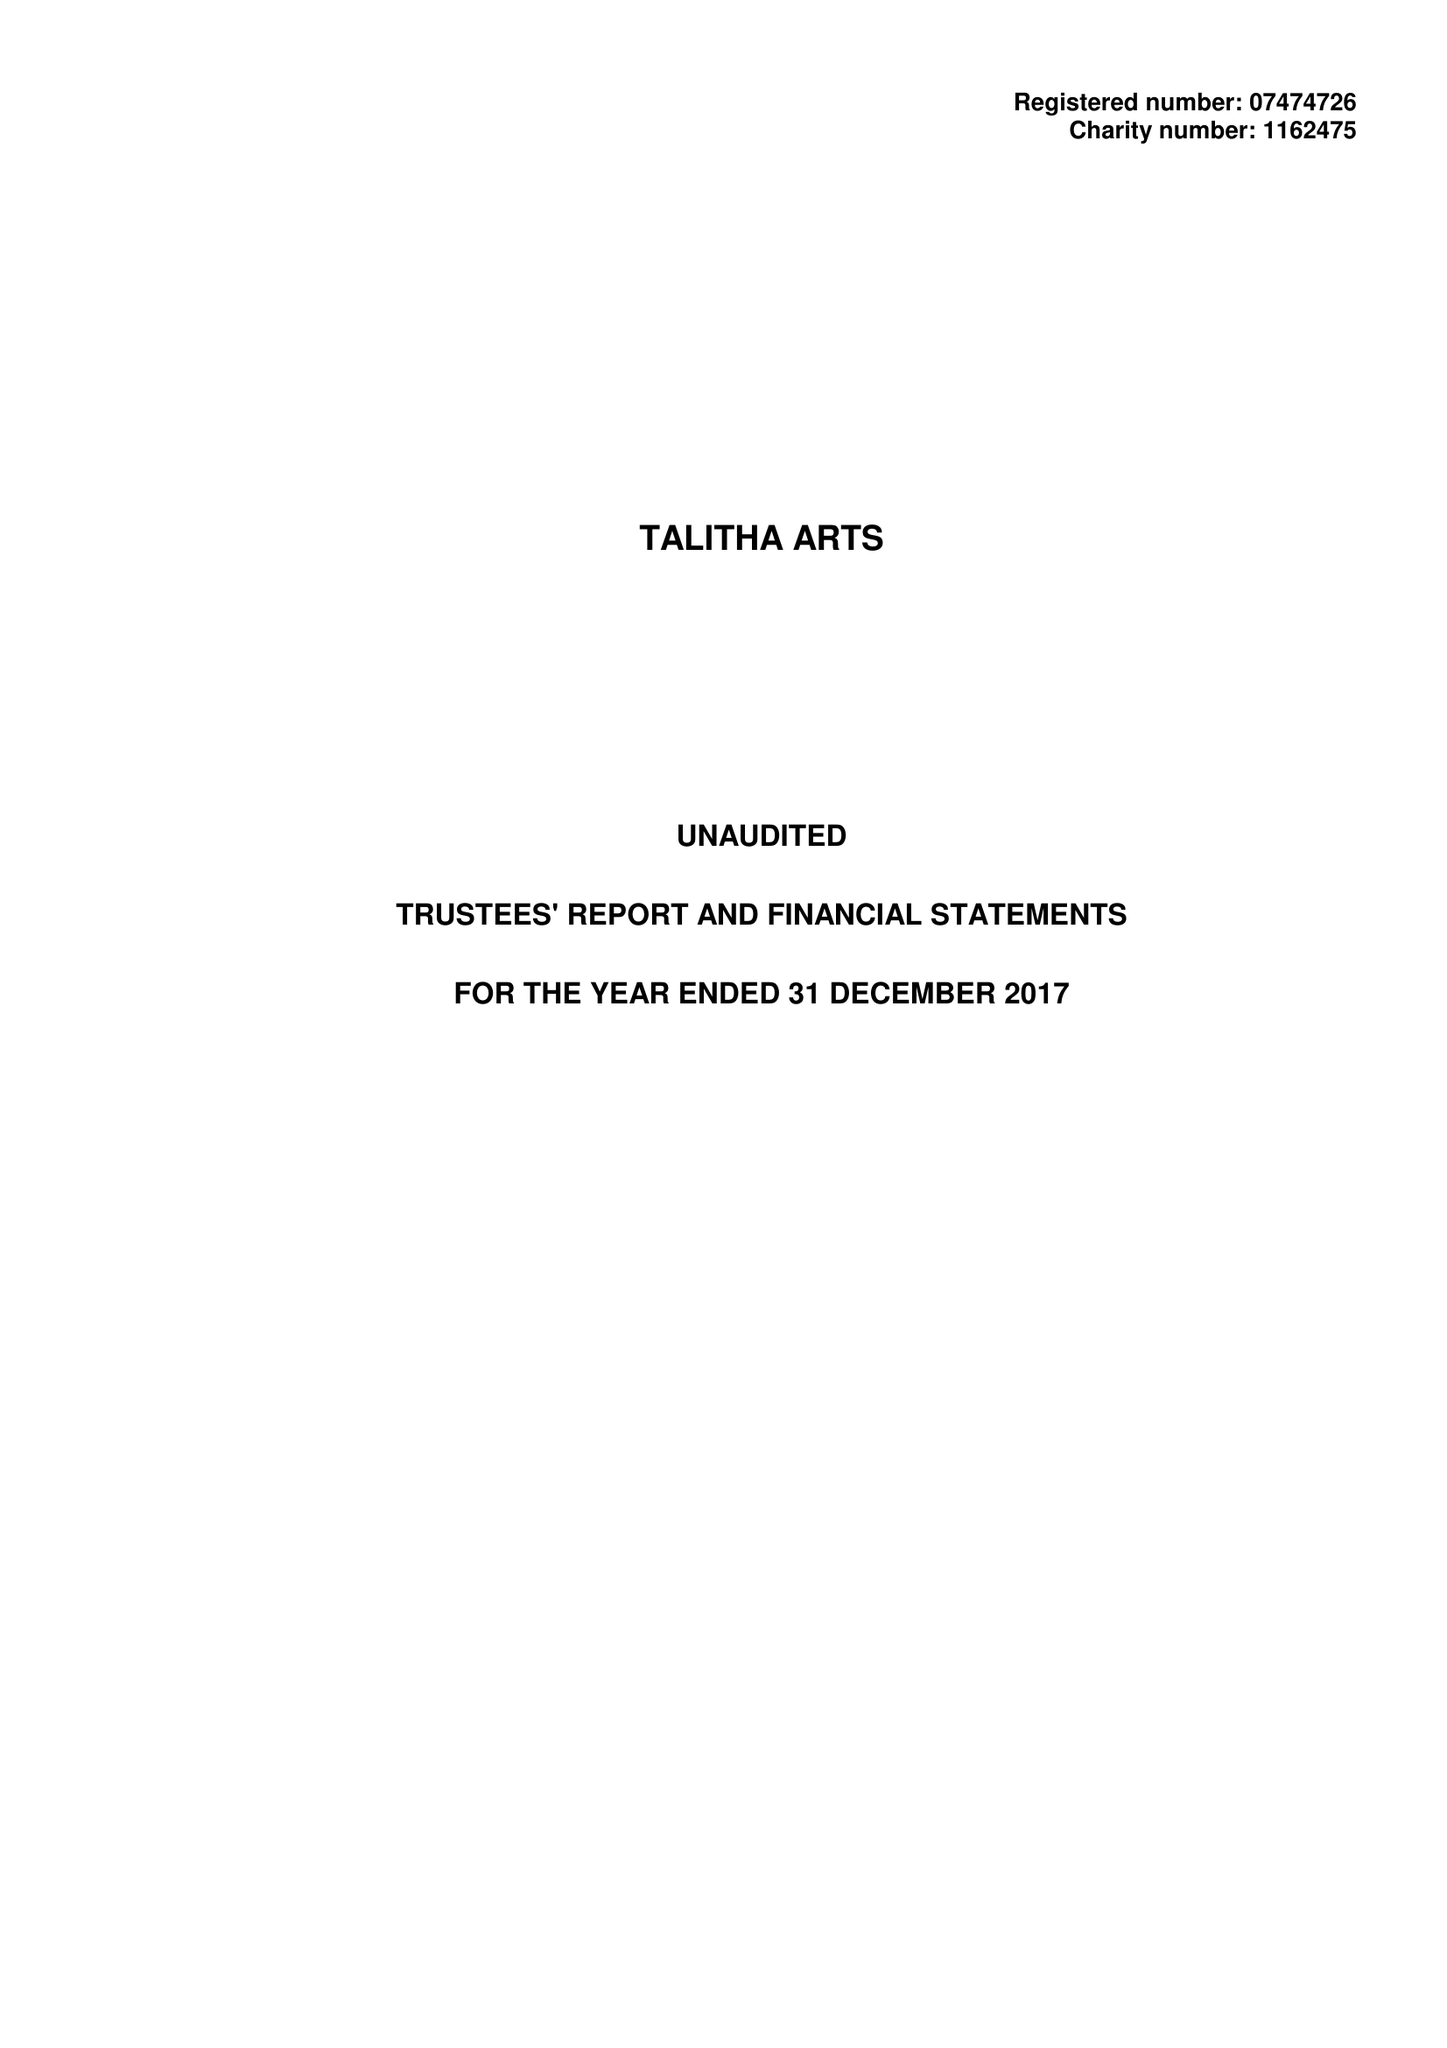What is the value for the address__post_town?
Answer the question using a single word or phrase. TEDDINGTON 